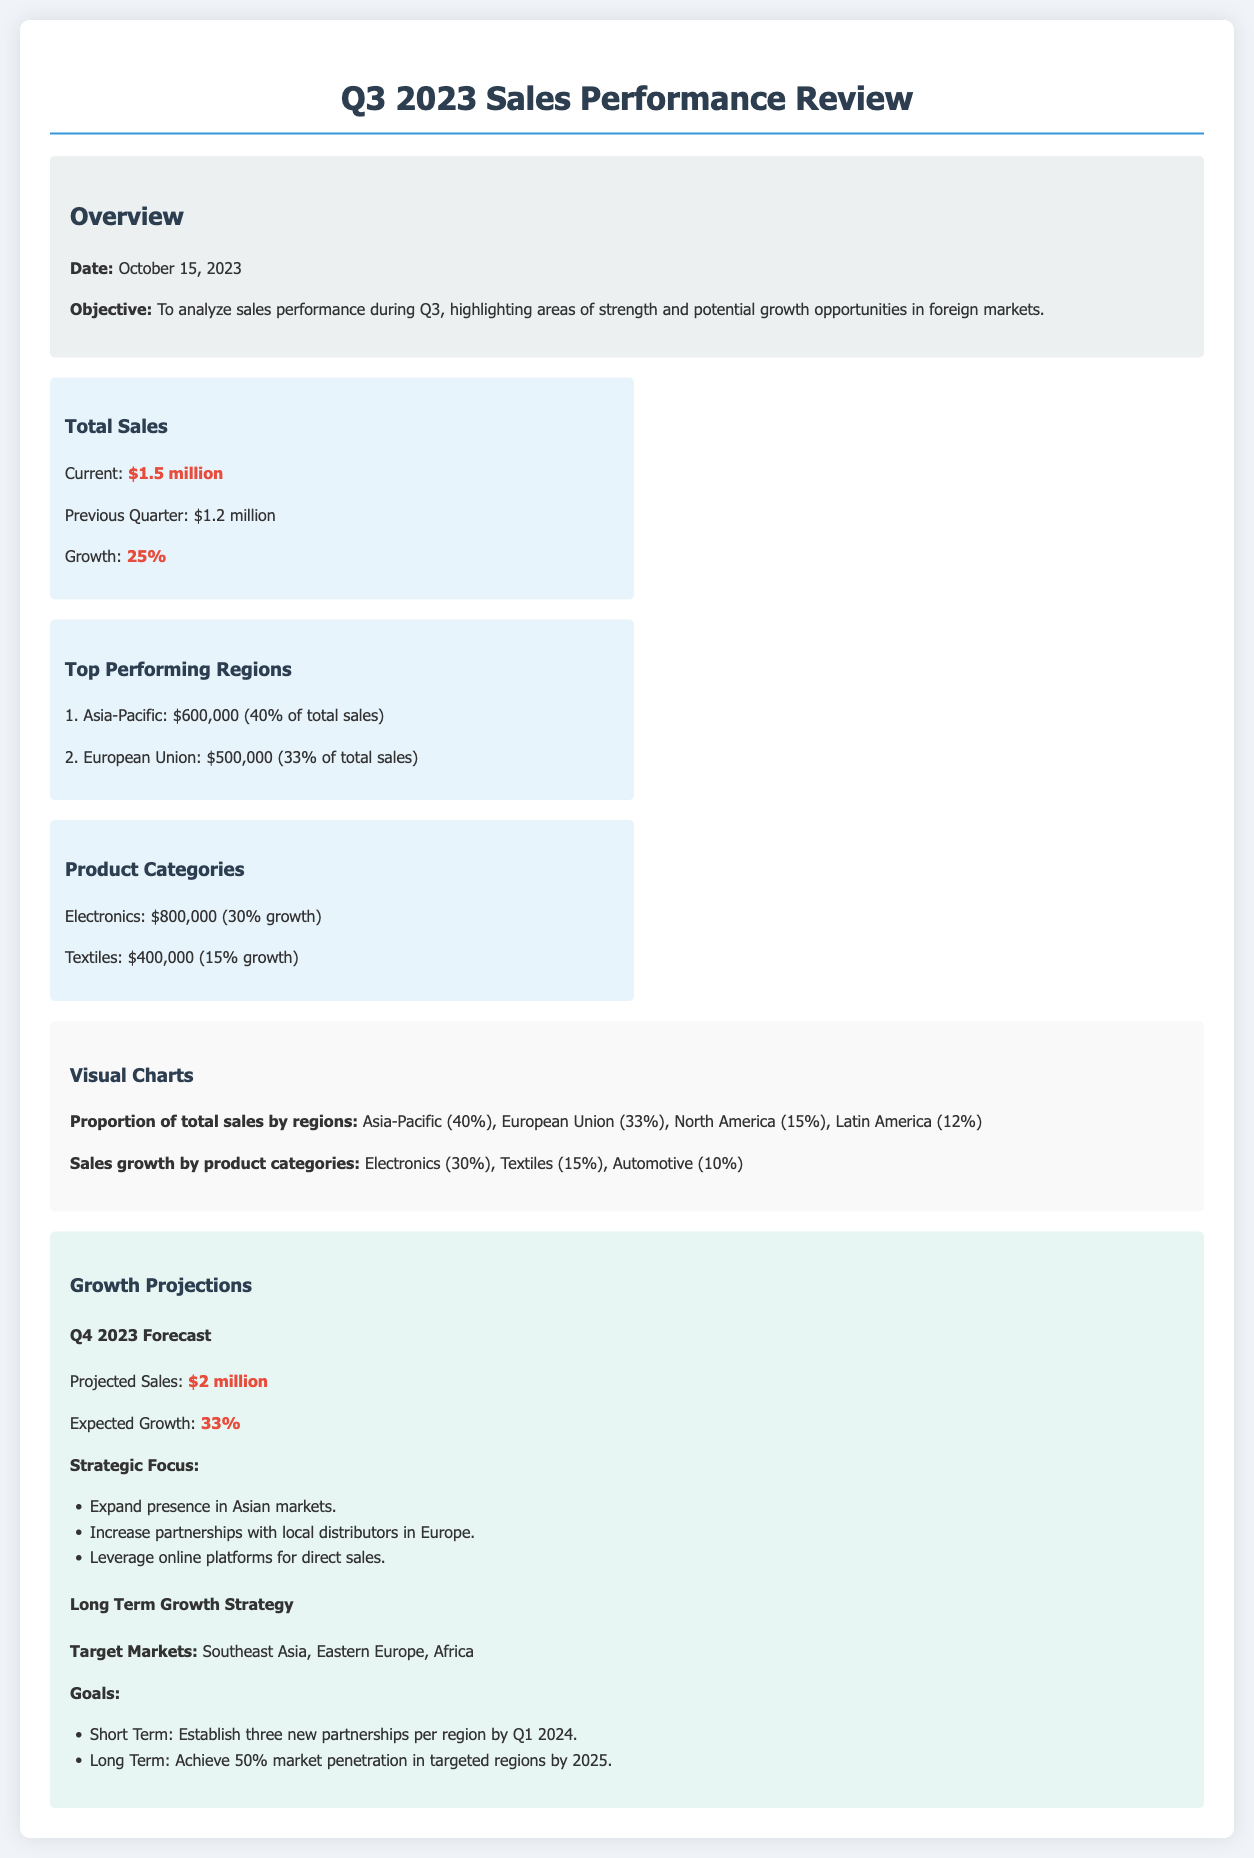What is the date of the review? The date of the review is explicitly stated in the document.
Answer: October 15, 2023 What was the total sales amount for Q3 2023? The total sales amount for Q3 2023 is highlighted in the performance section of the document.
Answer: $1.5 million What is the growth percentage compared to the previous quarter? The growth percentage is provided directly in the total sales performance information.
Answer: 25% Which region contributed the highest sales? The document specifies the regions and their contributions, highlighting the highest one.
Answer: Asia-Pacific What is the projected sales amount for Q4 2023? The projected sales amount is mentioned in the growth projections section of the document.
Answer: $2 million What is the expected growth percentage for Q4 2023? The expected growth is clearly stated in the growth projections.
Answer: 33% How much did Electronics sales grow in Q3 2023? The growth percentage for Electronics sales in Q3 is provided.
Answer: 30% Which market is emphasized for expansion? The strategic focus section specifies the markets for expansion.
Answer: Asian markets What are the target regions for long-term growth? The document lists the target markets under the long-term growth strategy.
Answer: Southeast Asia, Eastern Europe, Africa 